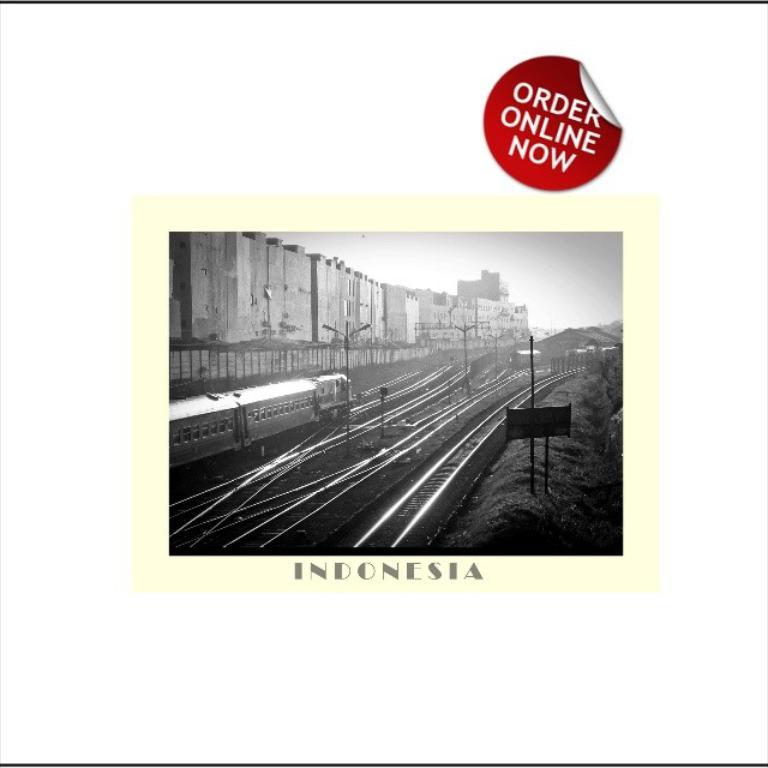When can you order online?
Offer a very short reply. Now. 